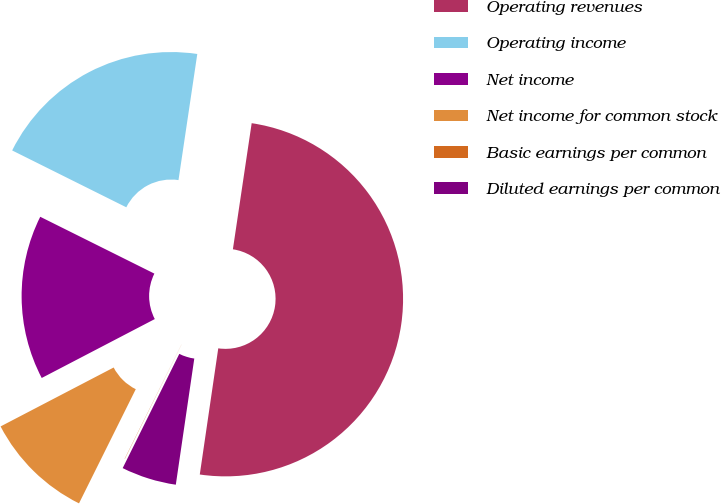<chart> <loc_0><loc_0><loc_500><loc_500><pie_chart><fcel>Operating revenues<fcel>Operating income<fcel>Net income<fcel>Net income for common stock<fcel>Basic earnings per common<fcel>Diluted earnings per common<nl><fcel>49.96%<fcel>20.0%<fcel>15.0%<fcel>10.01%<fcel>0.02%<fcel>5.01%<nl></chart> 